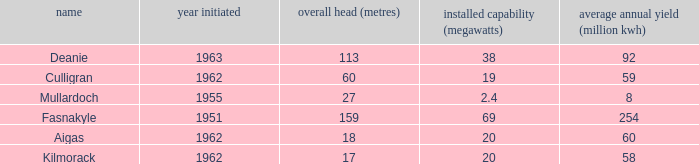What is the Year Commissioned of the power stationo with a Gross head of less than 18? 1962.0. 